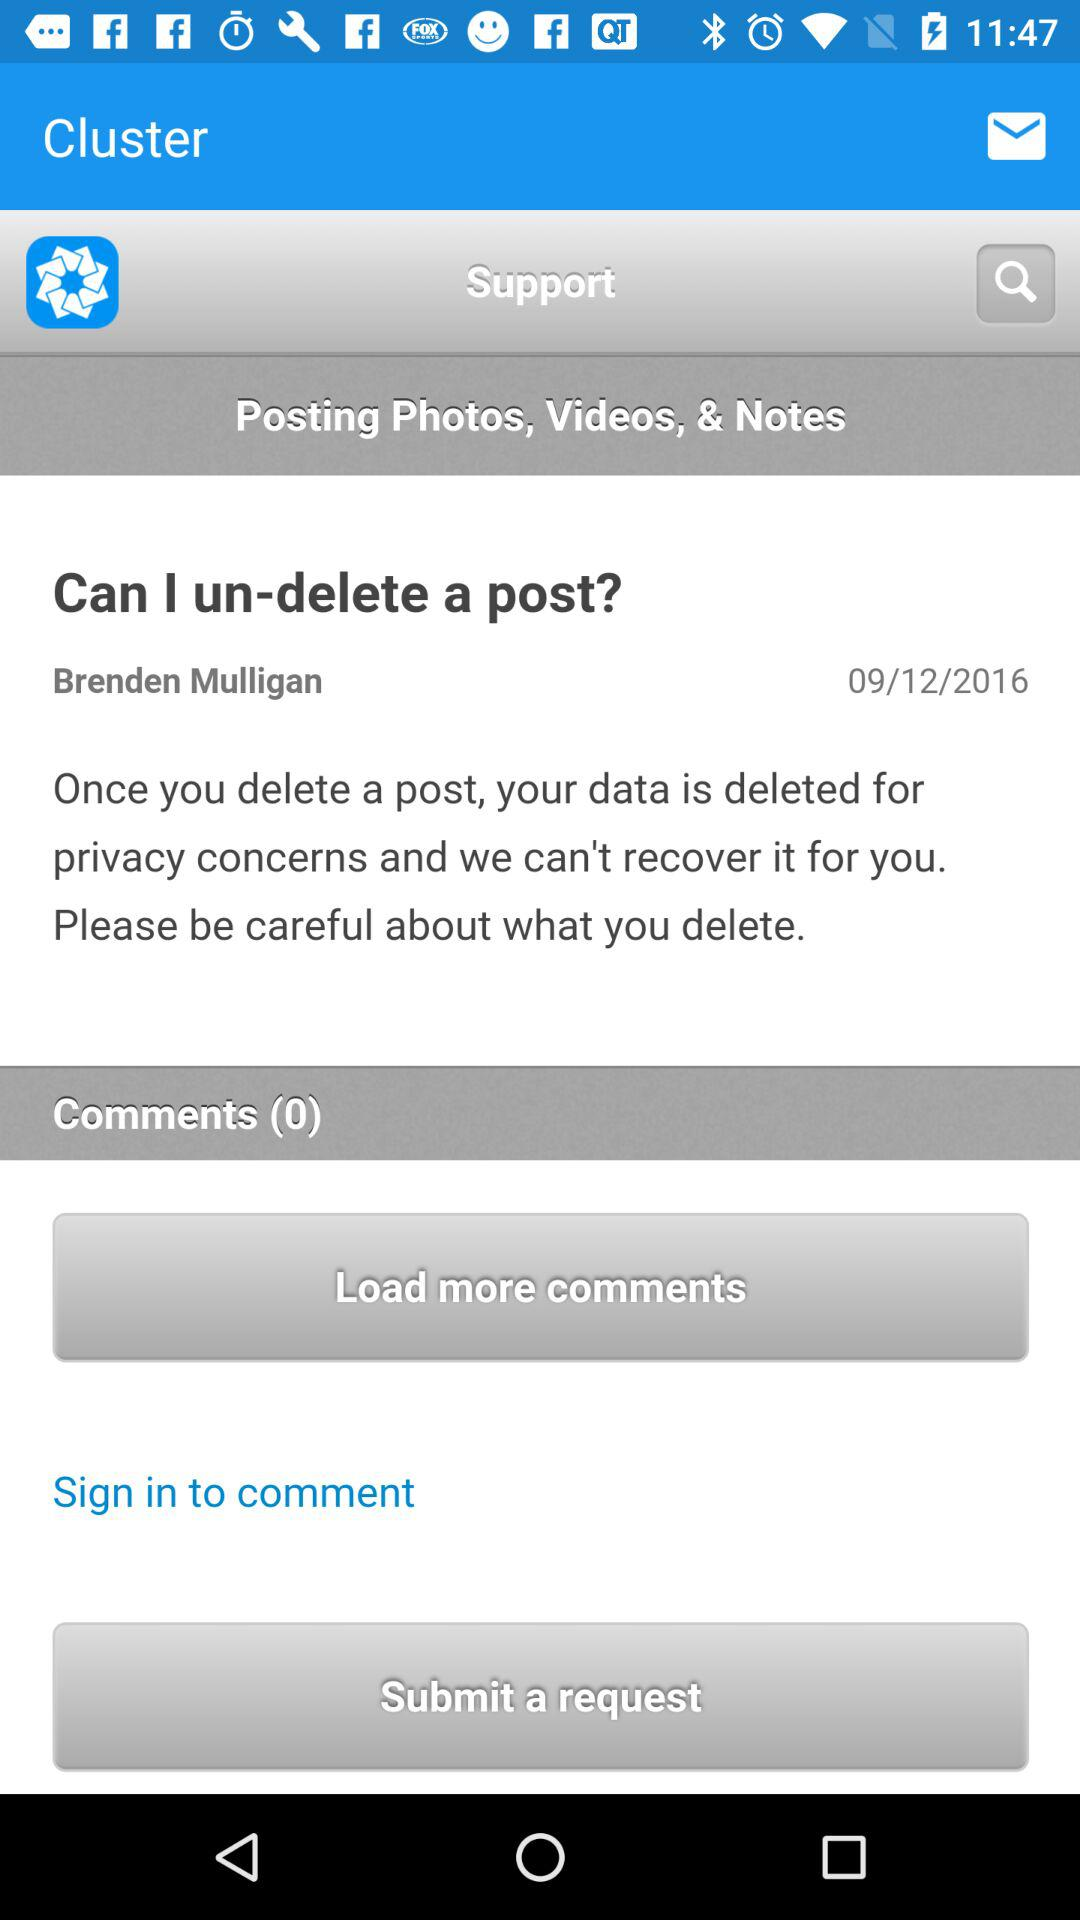What is the name of the user? The name of the user is Brenden Mulligan. 